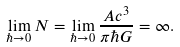Convert formula to latex. <formula><loc_0><loc_0><loc_500><loc_500>\lim _ { \hbar { \to } 0 } N = \lim _ { \hbar { \to } 0 } \frac { A c ^ { 3 } } { \pi \hbar { G } } = \infty .</formula> 